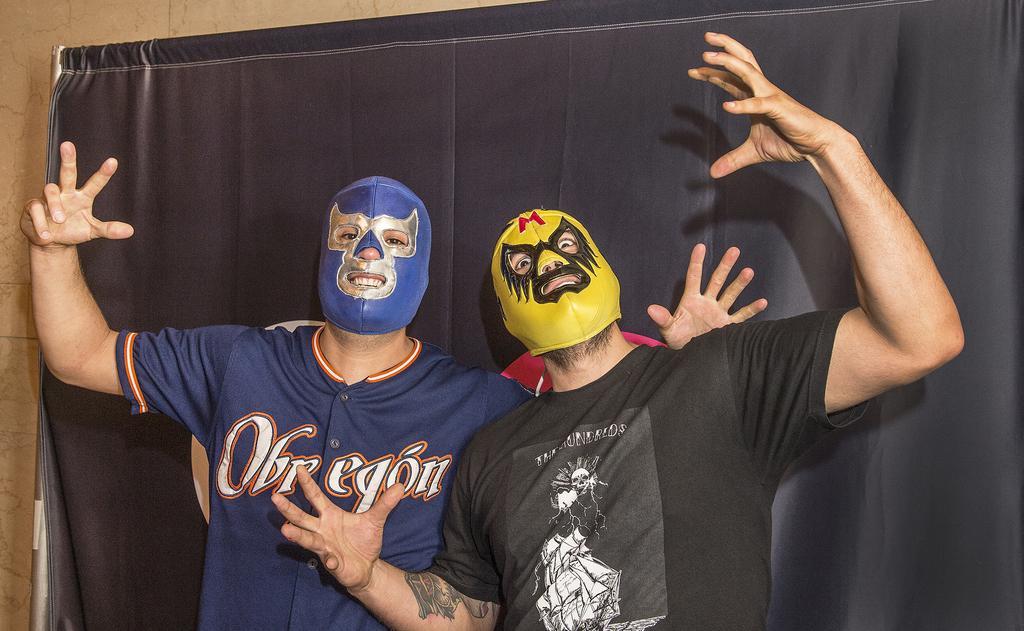Could you give a brief overview of what you see in this image? In the foreground of the picture there are two people wearing masks, behind them there is a black curtain. On the left it is well. 